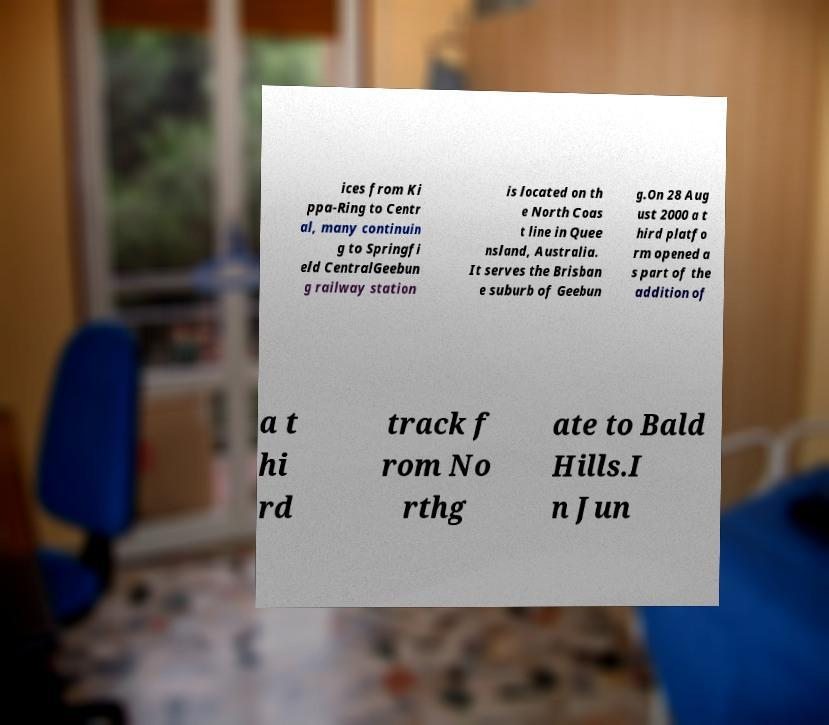I need the written content from this picture converted into text. Can you do that? ices from Ki ppa-Ring to Centr al, many continuin g to Springfi eld CentralGeebun g railway station is located on th e North Coas t line in Quee nsland, Australia. It serves the Brisban e suburb of Geebun g.On 28 Aug ust 2000 a t hird platfo rm opened a s part of the addition of a t hi rd track f rom No rthg ate to Bald Hills.I n Jun 